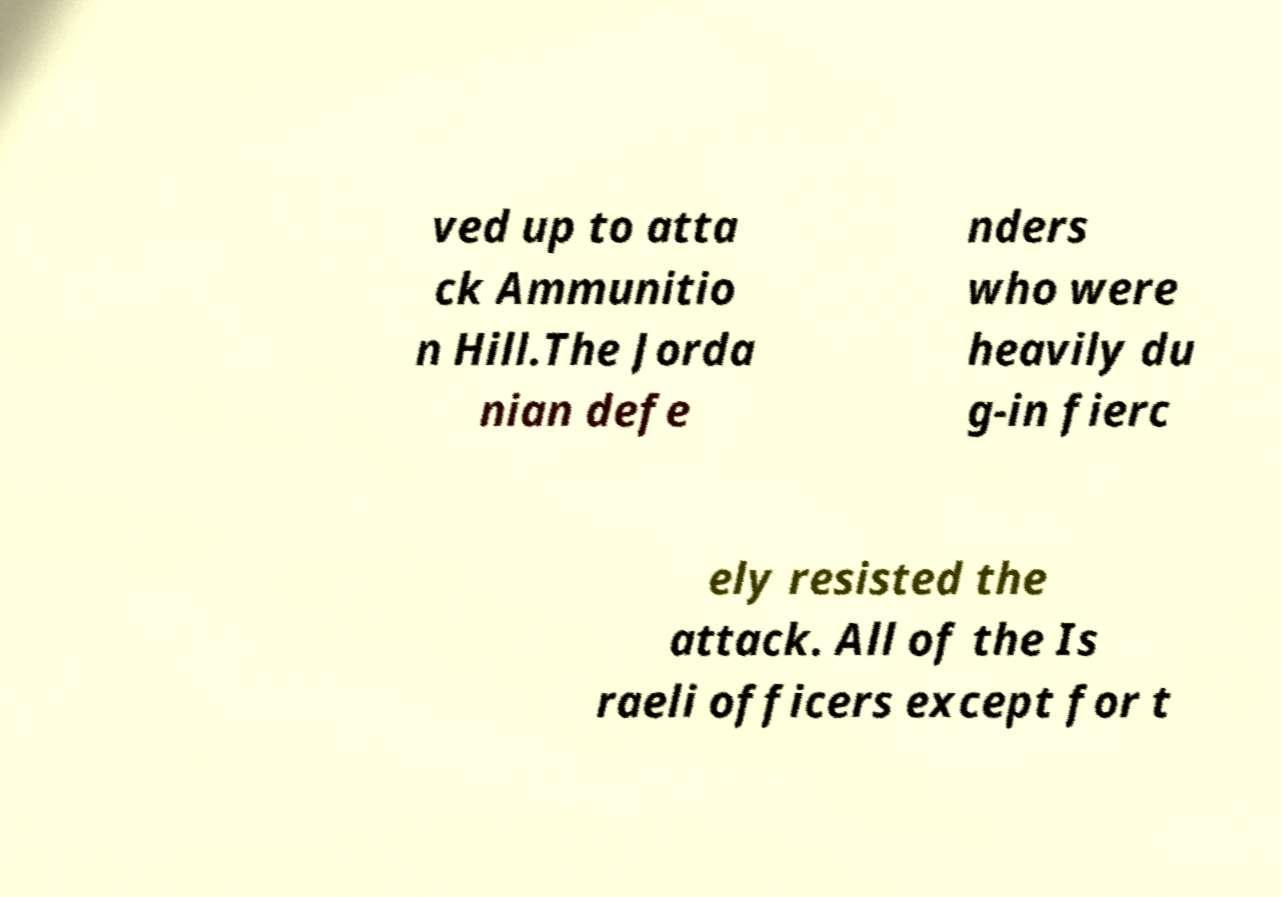There's text embedded in this image that I need extracted. Can you transcribe it verbatim? ved up to atta ck Ammunitio n Hill.The Jorda nian defe nders who were heavily du g-in fierc ely resisted the attack. All of the Is raeli officers except for t 